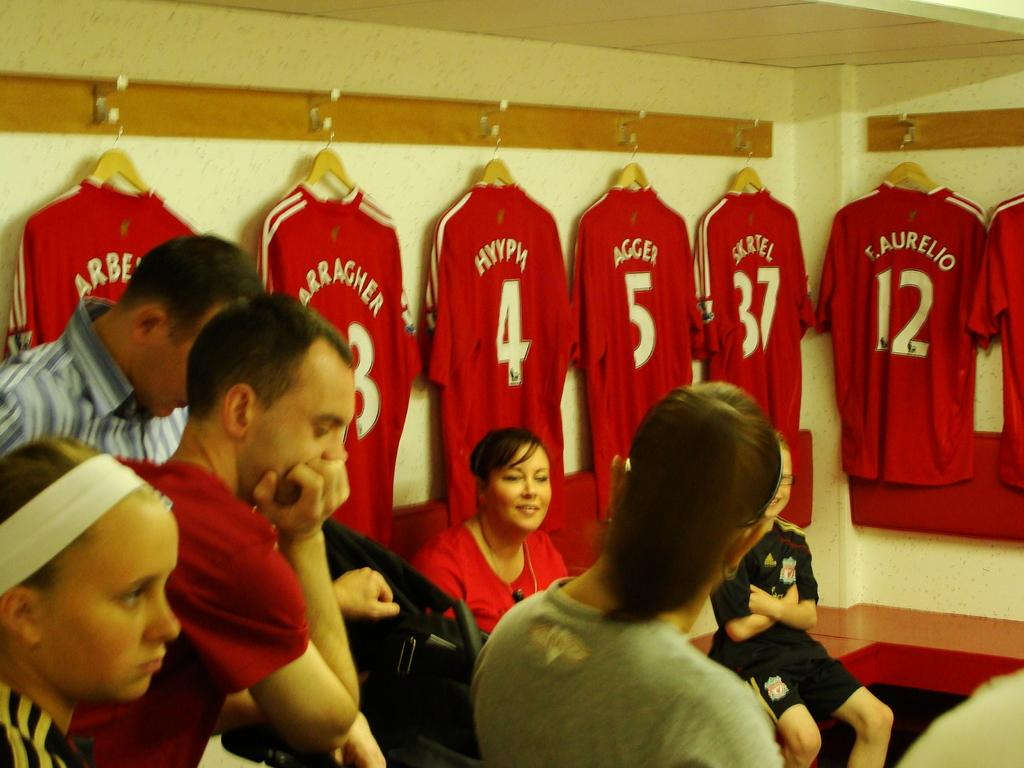<image>
Share a concise interpretation of the image provided. Members of the public tour Liverpool FC's dressing room and see the numbered and named shirts on hangers 